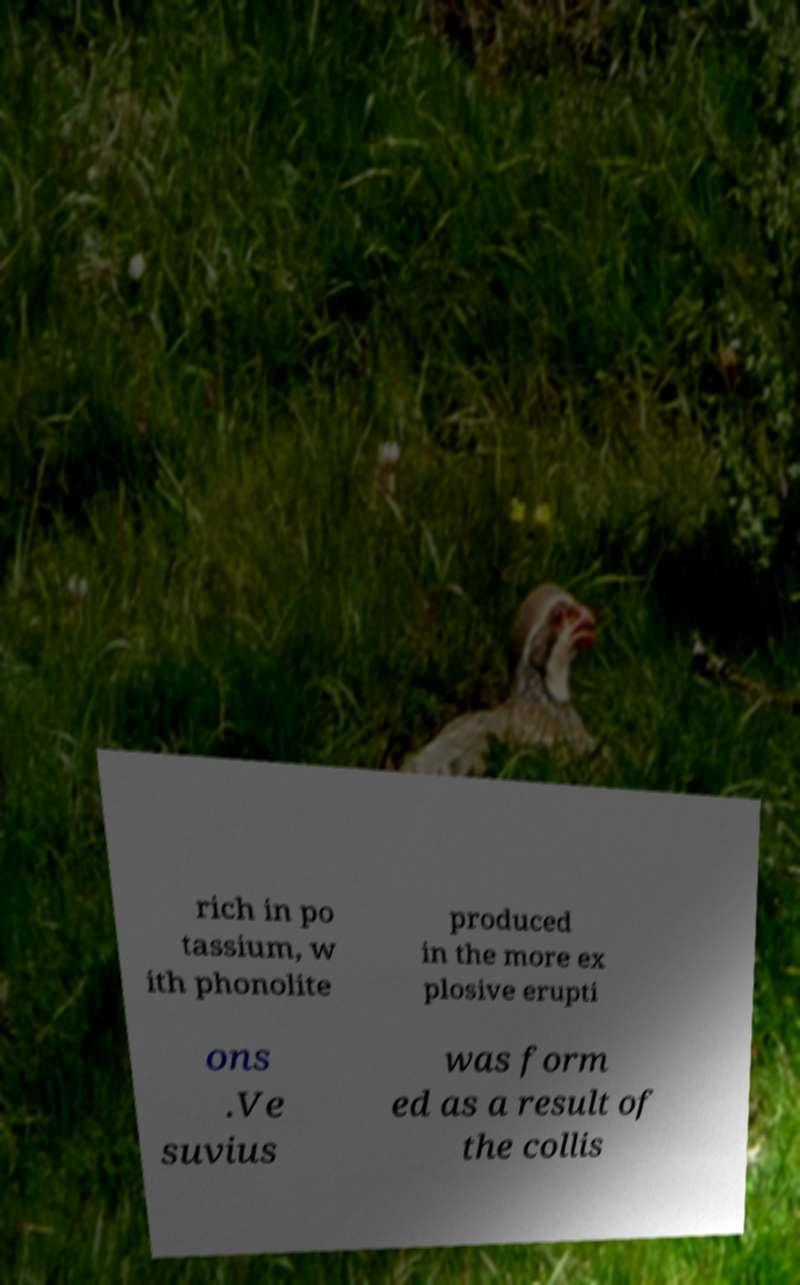Can you read and provide the text displayed in the image?This photo seems to have some interesting text. Can you extract and type it out for me? rich in po tassium, w ith phonolite produced in the more ex plosive erupti ons .Ve suvius was form ed as a result of the collis 